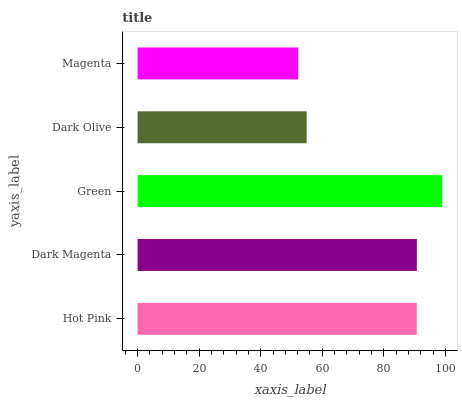Is Magenta the minimum?
Answer yes or no. Yes. Is Green the maximum?
Answer yes or no. Yes. Is Dark Magenta the minimum?
Answer yes or no. No. Is Dark Magenta the maximum?
Answer yes or no. No. Is Dark Magenta greater than Hot Pink?
Answer yes or no. Yes. Is Hot Pink less than Dark Magenta?
Answer yes or no. Yes. Is Hot Pink greater than Dark Magenta?
Answer yes or no. No. Is Dark Magenta less than Hot Pink?
Answer yes or no. No. Is Hot Pink the high median?
Answer yes or no. Yes. Is Hot Pink the low median?
Answer yes or no. Yes. Is Dark Magenta the high median?
Answer yes or no. No. Is Dark Olive the low median?
Answer yes or no. No. 